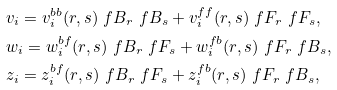<formula> <loc_0><loc_0><loc_500><loc_500>& v _ { i } = v ^ { b b } _ { i } ( r , s ) \ f B _ { r } \ f B _ { s } + v ^ { f f } _ { i } ( r , s ) \ f F _ { r } \ f F _ { s } , \\ & w _ { i } = w ^ { b f } _ { i } ( r , s ) \ f B _ { r } \ f F _ { s } + w ^ { f b } _ { i } ( r , s ) \ f F _ { r } \ f B _ { s } , \\ & z _ { i } = z ^ { b f } _ { i } ( r , s ) \ f B _ { r } \ f F _ { s } + z ^ { f b } _ { i } ( r , s ) \ f F _ { r } \ f B _ { s } ,</formula> 